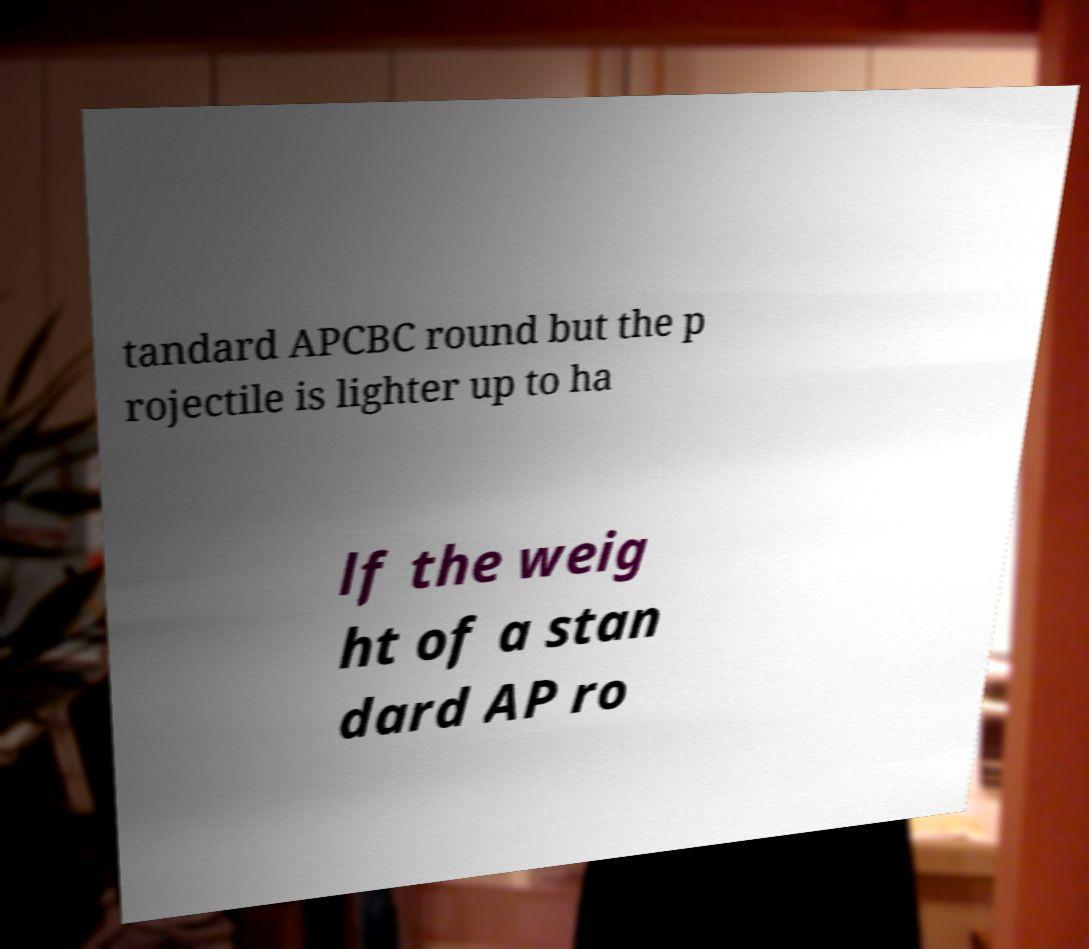What messages or text are displayed in this image? I need them in a readable, typed format. tandard APCBC round but the p rojectile is lighter up to ha lf the weig ht of a stan dard AP ro 